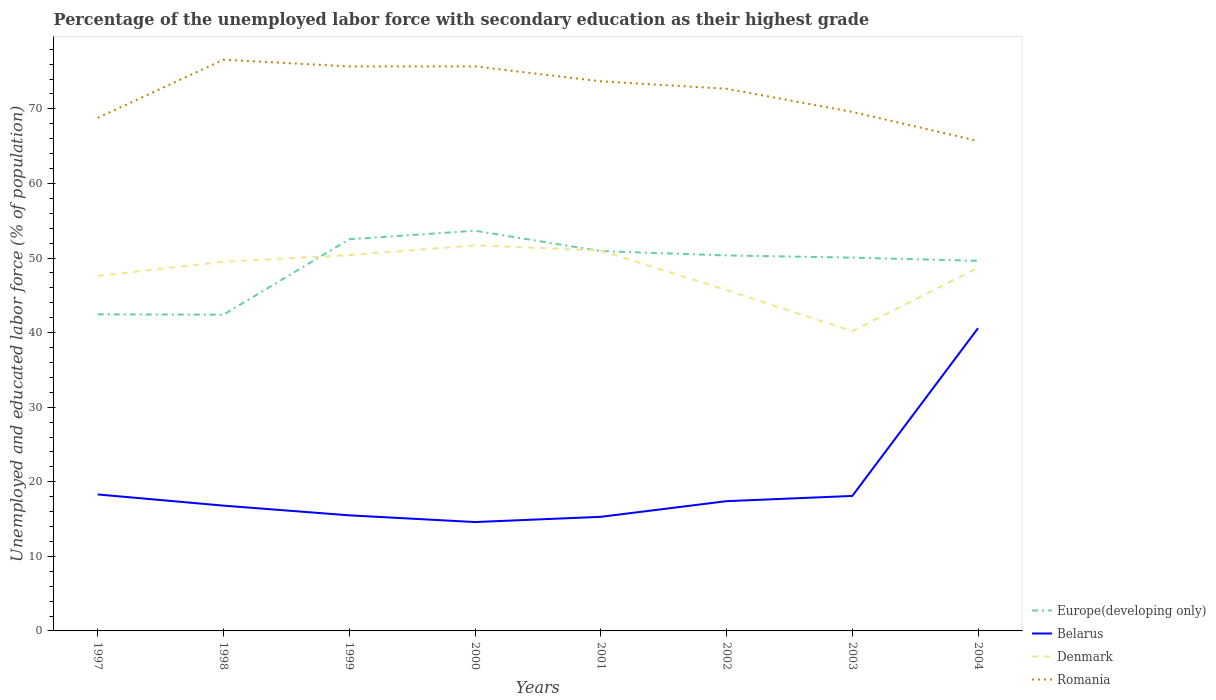Across all years, what is the maximum percentage of the unemployed labor force with secondary education in Romania?
Provide a short and direct response. 65.7. What is the total percentage of the unemployed labor force with secondary education in Romania in the graph?
Provide a short and direct response. 3.1. What is the difference between the highest and the second highest percentage of the unemployed labor force with secondary education in Europe(developing only)?
Offer a very short reply. 11.26. What is the difference between the highest and the lowest percentage of the unemployed labor force with secondary education in Europe(developing only)?
Your answer should be compact. 6. How many years are there in the graph?
Keep it short and to the point. 8. Are the values on the major ticks of Y-axis written in scientific E-notation?
Make the answer very short. No. Where does the legend appear in the graph?
Ensure brevity in your answer.  Bottom right. How are the legend labels stacked?
Give a very brief answer. Vertical. What is the title of the graph?
Ensure brevity in your answer.  Percentage of the unemployed labor force with secondary education as their highest grade. Does "Morocco" appear as one of the legend labels in the graph?
Offer a terse response. No. What is the label or title of the Y-axis?
Your answer should be very brief. Unemployed and educated labor force (% of population). What is the Unemployed and educated labor force (% of population) of Europe(developing only) in 1997?
Provide a succinct answer. 42.45. What is the Unemployed and educated labor force (% of population) in Belarus in 1997?
Give a very brief answer. 18.3. What is the Unemployed and educated labor force (% of population) of Denmark in 1997?
Your response must be concise. 47.6. What is the Unemployed and educated labor force (% of population) in Romania in 1997?
Make the answer very short. 68.8. What is the Unemployed and educated labor force (% of population) in Europe(developing only) in 1998?
Your answer should be compact. 42.41. What is the Unemployed and educated labor force (% of population) of Belarus in 1998?
Your answer should be very brief. 16.8. What is the Unemployed and educated labor force (% of population) of Denmark in 1998?
Your answer should be compact. 49.5. What is the Unemployed and educated labor force (% of population) in Romania in 1998?
Keep it short and to the point. 76.6. What is the Unemployed and educated labor force (% of population) in Europe(developing only) in 1999?
Your answer should be very brief. 52.52. What is the Unemployed and educated labor force (% of population) of Belarus in 1999?
Keep it short and to the point. 15.5. What is the Unemployed and educated labor force (% of population) in Denmark in 1999?
Offer a terse response. 50.4. What is the Unemployed and educated labor force (% of population) in Romania in 1999?
Offer a terse response. 75.7. What is the Unemployed and educated labor force (% of population) in Europe(developing only) in 2000?
Your answer should be compact. 53.66. What is the Unemployed and educated labor force (% of population) of Belarus in 2000?
Provide a short and direct response. 14.6. What is the Unemployed and educated labor force (% of population) of Denmark in 2000?
Your answer should be compact. 51.7. What is the Unemployed and educated labor force (% of population) of Romania in 2000?
Give a very brief answer. 75.7. What is the Unemployed and educated labor force (% of population) in Europe(developing only) in 2001?
Offer a terse response. 50.93. What is the Unemployed and educated labor force (% of population) in Belarus in 2001?
Your answer should be compact. 15.3. What is the Unemployed and educated labor force (% of population) of Denmark in 2001?
Your response must be concise. 51. What is the Unemployed and educated labor force (% of population) of Romania in 2001?
Offer a terse response. 73.7. What is the Unemployed and educated labor force (% of population) in Europe(developing only) in 2002?
Provide a succinct answer. 50.35. What is the Unemployed and educated labor force (% of population) in Belarus in 2002?
Keep it short and to the point. 17.4. What is the Unemployed and educated labor force (% of population) in Denmark in 2002?
Make the answer very short. 45.7. What is the Unemployed and educated labor force (% of population) of Romania in 2002?
Provide a succinct answer. 72.7. What is the Unemployed and educated labor force (% of population) in Europe(developing only) in 2003?
Your answer should be compact. 50.06. What is the Unemployed and educated labor force (% of population) of Belarus in 2003?
Ensure brevity in your answer.  18.1. What is the Unemployed and educated labor force (% of population) of Denmark in 2003?
Provide a succinct answer. 40.2. What is the Unemployed and educated labor force (% of population) of Romania in 2003?
Make the answer very short. 69.6. What is the Unemployed and educated labor force (% of population) in Europe(developing only) in 2004?
Make the answer very short. 49.63. What is the Unemployed and educated labor force (% of population) in Belarus in 2004?
Your answer should be compact. 40.6. What is the Unemployed and educated labor force (% of population) in Denmark in 2004?
Offer a very short reply. 48.7. What is the Unemployed and educated labor force (% of population) in Romania in 2004?
Provide a short and direct response. 65.7. Across all years, what is the maximum Unemployed and educated labor force (% of population) in Europe(developing only)?
Give a very brief answer. 53.66. Across all years, what is the maximum Unemployed and educated labor force (% of population) of Belarus?
Keep it short and to the point. 40.6. Across all years, what is the maximum Unemployed and educated labor force (% of population) of Denmark?
Your response must be concise. 51.7. Across all years, what is the maximum Unemployed and educated labor force (% of population) of Romania?
Your response must be concise. 76.6. Across all years, what is the minimum Unemployed and educated labor force (% of population) in Europe(developing only)?
Provide a succinct answer. 42.41. Across all years, what is the minimum Unemployed and educated labor force (% of population) of Belarus?
Provide a short and direct response. 14.6. Across all years, what is the minimum Unemployed and educated labor force (% of population) in Denmark?
Offer a terse response. 40.2. Across all years, what is the minimum Unemployed and educated labor force (% of population) of Romania?
Provide a succinct answer. 65.7. What is the total Unemployed and educated labor force (% of population) of Europe(developing only) in the graph?
Offer a terse response. 392.02. What is the total Unemployed and educated labor force (% of population) in Belarus in the graph?
Provide a short and direct response. 156.6. What is the total Unemployed and educated labor force (% of population) of Denmark in the graph?
Your answer should be very brief. 384.8. What is the total Unemployed and educated labor force (% of population) in Romania in the graph?
Provide a succinct answer. 578.5. What is the difference between the Unemployed and educated labor force (% of population) in Europe(developing only) in 1997 and that in 1998?
Your answer should be very brief. 0.05. What is the difference between the Unemployed and educated labor force (% of population) of Romania in 1997 and that in 1998?
Your answer should be compact. -7.8. What is the difference between the Unemployed and educated labor force (% of population) of Europe(developing only) in 1997 and that in 1999?
Your response must be concise. -10.07. What is the difference between the Unemployed and educated labor force (% of population) in Europe(developing only) in 1997 and that in 2000?
Keep it short and to the point. -11.21. What is the difference between the Unemployed and educated labor force (% of population) of Denmark in 1997 and that in 2000?
Give a very brief answer. -4.1. What is the difference between the Unemployed and educated labor force (% of population) of Romania in 1997 and that in 2000?
Provide a short and direct response. -6.9. What is the difference between the Unemployed and educated labor force (% of population) in Europe(developing only) in 1997 and that in 2001?
Provide a succinct answer. -8.48. What is the difference between the Unemployed and educated labor force (% of population) in Europe(developing only) in 1997 and that in 2002?
Offer a terse response. -7.9. What is the difference between the Unemployed and educated labor force (% of population) in Denmark in 1997 and that in 2002?
Make the answer very short. 1.9. What is the difference between the Unemployed and educated labor force (% of population) of Romania in 1997 and that in 2002?
Make the answer very short. -3.9. What is the difference between the Unemployed and educated labor force (% of population) in Europe(developing only) in 1997 and that in 2003?
Offer a terse response. -7.61. What is the difference between the Unemployed and educated labor force (% of population) of Romania in 1997 and that in 2003?
Give a very brief answer. -0.8. What is the difference between the Unemployed and educated labor force (% of population) in Europe(developing only) in 1997 and that in 2004?
Offer a very short reply. -7.17. What is the difference between the Unemployed and educated labor force (% of population) of Belarus in 1997 and that in 2004?
Provide a short and direct response. -22.3. What is the difference between the Unemployed and educated labor force (% of population) in Denmark in 1997 and that in 2004?
Offer a terse response. -1.1. What is the difference between the Unemployed and educated labor force (% of population) of Europe(developing only) in 1998 and that in 1999?
Give a very brief answer. -10.12. What is the difference between the Unemployed and educated labor force (% of population) in Europe(developing only) in 1998 and that in 2000?
Offer a terse response. -11.26. What is the difference between the Unemployed and educated labor force (% of population) in Denmark in 1998 and that in 2000?
Ensure brevity in your answer.  -2.2. What is the difference between the Unemployed and educated labor force (% of population) of Europe(developing only) in 1998 and that in 2001?
Your answer should be very brief. -8.53. What is the difference between the Unemployed and educated labor force (% of population) in Romania in 1998 and that in 2001?
Ensure brevity in your answer.  2.9. What is the difference between the Unemployed and educated labor force (% of population) of Europe(developing only) in 1998 and that in 2002?
Your answer should be very brief. -7.94. What is the difference between the Unemployed and educated labor force (% of population) of Belarus in 1998 and that in 2002?
Ensure brevity in your answer.  -0.6. What is the difference between the Unemployed and educated labor force (% of population) of Europe(developing only) in 1998 and that in 2003?
Give a very brief answer. -7.65. What is the difference between the Unemployed and educated labor force (% of population) of Denmark in 1998 and that in 2003?
Your answer should be compact. 9.3. What is the difference between the Unemployed and educated labor force (% of population) in Europe(developing only) in 1998 and that in 2004?
Your answer should be compact. -7.22. What is the difference between the Unemployed and educated labor force (% of population) of Belarus in 1998 and that in 2004?
Provide a short and direct response. -23.8. What is the difference between the Unemployed and educated labor force (% of population) in Romania in 1998 and that in 2004?
Provide a short and direct response. 10.9. What is the difference between the Unemployed and educated labor force (% of population) of Europe(developing only) in 1999 and that in 2000?
Give a very brief answer. -1.14. What is the difference between the Unemployed and educated labor force (% of population) of Belarus in 1999 and that in 2000?
Offer a very short reply. 0.9. What is the difference between the Unemployed and educated labor force (% of population) of Denmark in 1999 and that in 2000?
Keep it short and to the point. -1.3. What is the difference between the Unemployed and educated labor force (% of population) in Europe(developing only) in 1999 and that in 2001?
Make the answer very short. 1.59. What is the difference between the Unemployed and educated labor force (% of population) in Denmark in 1999 and that in 2001?
Keep it short and to the point. -0.6. What is the difference between the Unemployed and educated labor force (% of population) of Romania in 1999 and that in 2001?
Give a very brief answer. 2. What is the difference between the Unemployed and educated labor force (% of population) of Europe(developing only) in 1999 and that in 2002?
Keep it short and to the point. 2.17. What is the difference between the Unemployed and educated labor force (% of population) of Denmark in 1999 and that in 2002?
Keep it short and to the point. 4.7. What is the difference between the Unemployed and educated labor force (% of population) of Europe(developing only) in 1999 and that in 2003?
Make the answer very short. 2.46. What is the difference between the Unemployed and educated labor force (% of population) in Romania in 1999 and that in 2003?
Make the answer very short. 6.1. What is the difference between the Unemployed and educated labor force (% of population) in Europe(developing only) in 1999 and that in 2004?
Keep it short and to the point. 2.9. What is the difference between the Unemployed and educated labor force (% of population) of Belarus in 1999 and that in 2004?
Provide a succinct answer. -25.1. What is the difference between the Unemployed and educated labor force (% of population) in Denmark in 1999 and that in 2004?
Make the answer very short. 1.7. What is the difference between the Unemployed and educated labor force (% of population) of Europe(developing only) in 2000 and that in 2001?
Provide a short and direct response. 2.73. What is the difference between the Unemployed and educated labor force (% of population) in Belarus in 2000 and that in 2001?
Your answer should be compact. -0.7. What is the difference between the Unemployed and educated labor force (% of population) in Europe(developing only) in 2000 and that in 2002?
Provide a succinct answer. 3.31. What is the difference between the Unemployed and educated labor force (% of population) in Romania in 2000 and that in 2002?
Provide a short and direct response. 3. What is the difference between the Unemployed and educated labor force (% of population) in Europe(developing only) in 2000 and that in 2003?
Give a very brief answer. 3.6. What is the difference between the Unemployed and educated labor force (% of population) in Denmark in 2000 and that in 2003?
Offer a very short reply. 11.5. What is the difference between the Unemployed and educated labor force (% of population) of Europe(developing only) in 2000 and that in 2004?
Your response must be concise. 4.04. What is the difference between the Unemployed and educated labor force (% of population) of Belarus in 2000 and that in 2004?
Keep it short and to the point. -26. What is the difference between the Unemployed and educated labor force (% of population) in Europe(developing only) in 2001 and that in 2002?
Make the answer very short. 0.58. What is the difference between the Unemployed and educated labor force (% of population) in Denmark in 2001 and that in 2002?
Make the answer very short. 5.3. What is the difference between the Unemployed and educated labor force (% of population) in Romania in 2001 and that in 2002?
Make the answer very short. 1. What is the difference between the Unemployed and educated labor force (% of population) in Europe(developing only) in 2001 and that in 2003?
Your answer should be compact. 0.88. What is the difference between the Unemployed and educated labor force (% of population) of Belarus in 2001 and that in 2003?
Provide a short and direct response. -2.8. What is the difference between the Unemployed and educated labor force (% of population) of Romania in 2001 and that in 2003?
Provide a succinct answer. 4.1. What is the difference between the Unemployed and educated labor force (% of population) of Europe(developing only) in 2001 and that in 2004?
Make the answer very short. 1.31. What is the difference between the Unemployed and educated labor force (% of population) in Belarus in 2001 and that in 2004?
Your response must be concise. -25.3. What is the difference between the Unemployed and educated labor force (% of population) of Romania in 2001 and that in 2004?
Make the answer very short. 8. What is the difference between the Unemployed and educated labor force (% of population) of Europe(developing only) in 2002 and that in 2003?
Keep it short and to the point. 0.29. What is the difference between the Unemployed and educated labor force (% of population) of Belarus in 2002 and that in 2003?
Offer a terse response. -0.7. What is the difference between the Unemployed and educated labor force (% of population) of Denmark in 2002 and that in 2003?
Give a very brief answer. 5.5. What is the difference between the Unemployed and educated labor force (% of population) in Romania in 2002 and that in 2003?
Your answer should be compact. 3.1. What is the difference between the Unemployed and educated labor force (% of population) of Europe(developing only) in 2002 and that in 2004?
Offer a very short reply. 0.72. What is the difference between the Unemployed and educated labor force (% of population) of Belarus in 2002 and that in 2004?
Offer a terse response. -23.2. What is the difference between the Unemployed and educated labor force (% of population) of Europe(developing only) in 2003 and that in 2004?
Your response must be concise. 0.43. What is the difference between the Unemployed and educated labor force (% of population) in Belarus in 2003 and that in 2004?
Your answer should be very brief. -22.5. What is the difference between the Unemployed and educated labor force (% of population) in Europe(developing only) in 1997 and the Unemployed and educated labor force (% of population) in Belarus in 1998?
Your answer should be very brief. 25.65. What is the difference between the Unemployed and educated labor force (% of population) of Europe(developing only) in 1997 and the Unemployed and educated labor force (% of population) of Denmark in 1998?
Keep it short and to the point. -7.05. What is the difference between the Unemployed and educated labor force (% of population) of Europe(developing only) in 1997 and the Unemployed and educated labor force (% of population) of Romania in 1998?
Make the answer very short. -34.15. What is the difference between the Unemployed and educated labor force (% of population) in Belarus in 1997 and the Unemployed and educated labor force (% of population) in Denmark in 1998?
Offer a terse response. -31.2. What is the difference between the Unemployed and educated labor force (% of population) of Belarus in 1997 and the Unemployed and educated labor force (% of population) of Romania in 1998?
Offer a very short reply. -58.3. What is the difference between the Unemployed and educated labor force (% of population) of Denmark in 1997 and the Unemployed and educated labor force (% of population) of Romania in 1998?
Keep it short and to the point. -29. What is the difference between the Unemployed and educated labor force (% of population) in Europe(developing only) in 1997 and the Unemployed and educated labor force (% of population) in Belarus in 1999?
Your response must be concise. 26.95. What is the difference between the Unemployed and educated labor force (% of population) of Europe(developing only) in 1997 and the Unemployed and educated labor force (% of population) of Denmark in 1999?
Keep it short and to the point. -7.95. What is the difference between the Unemployed and educated labor force (% of population) in Europe(developing only) in 1997 and the Unemployed and educated labor force (% of population) in Romania in 1999?
Your answer should be compact. -33.25. What is the difference between the Unemployed and educated labor force (% of population) in Belarus in 1997 and the Unemployed and educated labor force (% of population) in Denmark in 1999?
Your answer should be compact. -32.1. What is the difference between the Unemployed and educated labor force (% of population) in Belarus in 1997 and the Unemployed and educated labor force (% of population) in Romania in 1999?
Offer a terse response. -57.4. What is the difference between the Unemployed and educated labor force (% of population) in Denmark in 1997 and the Unemployed and educated labor force (% of population) in Romania in 1999?
Ensure brevity in your answer.  -28.1. What is the difference between the Unemployed and educated labor force (% of population) of Europe(developing only) in 1997 and the Unemployed and educated labor force (% of population) of Belarus in 2000?
Make the answer very short. 27.85. What is the difference between the Unemployed and educated labor force (% of population) of Europe(developing only) in 1997 and the Unemployed and educated labor force (% of population) of Denmark in 2000?
Keep it short and to the point. -9.25. What is the difference between the Unemployed and educated labor force (% of population) of Europe(developing only) in 1997 and the Unemployed and educated labor force (% of population) of Romania in 2000?
Provide a short and direct response. -33.25. What is the difference between the Unemployed and educated labor force (% of population) in Belarus in 1997 and the Unemployed and educated labor force (% of population) in Denmark in 2000?
Your answer should be very brief. -33.4. What is the difference between the Unemployed and educated labor force (% of population) in Belarus in 1997 and the Unemployed and educated labor force (% of population) in Romania in 2000?
Your answer should be very brief. -57.4. What is the difference between the Unemployed and educated labor force (% of population) of Denmark in 1997 and the Unemployed and educated labor force (% of population) of Romania in 2000?
Ensure brevity in your answer.  -28.1. What is the difference between the Unemployed and educated labor force (% of population) of Europe(developing only) in 1997 and the Unemployed and educated labor force (% of population) of Belarus in 2001?
Provide a short and direct response. 27.15. What is the difference between the Unemployed and educated labor force (% of population) of Europe(developing only) in 1997 and the Unemployed and educated labor force (% of population) of Denmark in 2001?
Offer a very short reply. -8.55. What is the difference between the Unemployed and educated labor force (% of population) of Europe(developing only) in 1997 and the Unemployed and educated labor force (% of population) of Romania in 2001?
Keep it short and to the point. -31.25. What is the difference between the Unemployed and educated labor force (% of population) in Belarus in 1997 and the Unemployed and educated labor force (% of population) in Denmark in 2001?
Your answer should be compact. -32.7. What is the difference between the Unemployed and educated labor force (% of population) in Belarus in 1997 and the Unemployed and educated labor force (% of population) in Romania in 2001?
Your response must be concise. -55.4. What is the difference between the Unemployed and educated labor force (% of population) in Denmark in 1997 and the Unemployed and educated labor force (% of population) in Romania in 2001?
Ensure brevity in your answer.  -26.1. What is the difference between the Unemployed and educated labor force (% of population) of Europe(developing only) in 1997 and the Unemployed and educated labor force (% of population) of Belarus in 2002?
Offer a terse response. 25.05. What is the difference between the Unemployed and educated labor force (% of population) of Europe(developing only) in 1997 and the Unemployed and educated labor force (% of population) of Denmark in 2002?
Your answer should be compact. -3.25. What is the difference between the Unemployed and educated labor force (% of population) of Europe(developing only) in 1997 and the Unemployed and educated labor force (% of population) of Romania in 2002?
Make the answer very short. -30.25. What is the difference between the Unemployed and educated labor force (% of population) in Belarus in 1997 and the Unemployed and educated labor force (% of population) in Denmark in 2002?
Keep it short and to the point. -27.4. What is the difference between the Unemployed and educated labor force (% of population) of Belarus in 1997 and the Unemployed and educated labor force (% of population) of Romania in 2002?
Give a very brief answer. -54.4. What is the difference between the Unemployed and educated labor force (% of population) in Denmark in 1997 and the Unemployed and educated labor force (% of population) in Romania in 2002?
Offer a very short reply. -25.1. What is the difference between the Unemployed and educated labor force (% of population) of Europe(developing only) in 1997 and the Unemployed and educated labor force (% of population) of Belarus in 2003?
Your answer should be compact. 24.35. What is the difference between the Unemployed and educated labor force (% of population) of Europe(developing only) in 1997 and the Unemployed and educated labor force (% of population) of Denmark in 2003?
Keep it short and to the point. 2.25. What is the difference between the Unemployed and educated labor force (% of population) of Europe(developing only) in 1997 and the Unemployed and educated labor force (% of population) of Romania in 2003?
Provide a short and direct response. -27.15. What is the difference between the Unemployed and educated labor force (% of population) of Belarus in 1997 and the Unemployed and educated labor force (% of population) of Denmark in 2003?
Your answer should be compact. -21.9. What is the difference between the Unemployed and educated labor force (% of population) in Belarus in 1997 and the Unemployed and educated labor force (% of population) in Romania in 2003?
Provide a short and direct response. -51.3. What is the difference between the Unemployed and educated labor force (% of population) in Denmark in 1997 and the Unemployed and educated labor force (% of population) in Romania in 2003?
Your answer should be compact. -22. What is the difference between the Unemployed and educated labor force (% of population) in Europe(developing only) in 1997 and the Unemployed and educated labor force (% of population) in Belarus in 2004?
Offer a very short reply. 1.85. What is the difference between the Unemployed and educated labor force (% of population) of Europe(developing only) in 1997 and the Unemployed and educated labor force (% of population) of Denmark in 2004?
Your response must be concise. -6.25. What is the difference between the Unemployed and educated labor force (% of population) of Europe(developing only) in 1997 and the Unemployed and educated labor force (% of population) of Romania in 2004?
Offer a terse response. -23.25. What is the difference between the Unemployed and educated labor force (% of population) of Belarus in 1997 and the Unemployed and educated labor force (% of population) of Denmark in 2004?
Your answer should be compact. -30.4. What is the difference between the Unemployed and educated labor force (% of population) of Belarus in 1997 and the Unemployed and educated labor force (% of population) of Romania in 2004?
Give a very brief answer. -47.4. What is the difference between the Unemployed and educated labor force (% of population) of Denmark in 1997 and the Unemployed and educated labor force (% of population) of Romania in 2004?
Offer a very short reply. -18.1. What is the difference between the Unemployed and educated labor force (% of population) in Europe(developing only) in 1998 and the Unemployed and educated labor force (% of population) in Belarus in 1999?
Offer a very short reply. 26.91. What is the difference between the Unemployed and educated labor force (% of population) of Europe(developing only) in 1998 and the Unemployed and educated labor force (% of population) of Denmark in 1999?
Offer a terse response. -7.99. What is the difference between the Unemployed and educated labor force (% of population) in Europe(developing only) in 1998 and the Unemployed and educated labor force (% of population) in Romania in 1999?
Ensure brevity in your answer.  -33.29. What is the difference between the Unemployed and educated labor force (% of population) of Belarus in 1998 and the Unemployed and educated labor force (% of population) of Denmark in 1999?
Keep it short and to the point. -33.6. What is the difference between the Unemployed and educated labor force (% of population) in Belarus in 1998 and the Unemployed and educated labor force (% of population) in Romania in 1999?
Your answer should be compact. -58.9. What is the difference between the Unemployed and educated labor force (% of population) in Denmark in 1998 and the Unemployed and educated labor force (% of population) in Romania in 1999?
Make the answer very short. -26.2. What is the difference between the Unemployed and educated labor force (% of population) in Europe(developing only) in 1998 and the Unemployed and educated labor force (% of population) in Belarus in 2000?
Your answer should be very brief. 27.81. What is the difference between the Unemployed and educated labor force (% of population) of Europe(developing only) in 1998 and the Unemployed and educated labor force (% of population) of Denmark in 2000?
Offer a very short reply. -9.29. What is the difference between the Unemployed and educated labor force (% of population) in Europe(developing only) in 1998 and the Unemployed and educated labor force (% of population) in Romania in 2000?
Your response must be concise. -33.29. What is the difference between the Unemployed and educated labor force (% of population) of Belarus in 1998 and the Unemployed and educated labor force (% of population) of Denmark in 2000?
Ensure brevity in your answer.  -34.9. What is the difference between the Unemployed and educated labor force (% of population) in Belarus in 1998 and the Unemployed and educated labor force (% of population) in Romania in 2000?
Offer a very short reply. -58.9. What is the difference between the Unemployed and educated labor force (% of population) of Denmark in 1998 and the Unemployed and educated labor force (% of population) of Romania in 2000?
Offer a very short reply. -26.2. What is the difference between the Unemployed and educated labor force (% of population) in Europe(developing only) in 1998 and the Unemployed and educated labor force (% of population) in Belarus in 2001?
Provide a short and direct response. 27.11. What is the difference between the Unemployed and educated labor force (% of population) of Europe(developing only) in 1998 and the Unemployed and educated labor force (% of population) of Denmark in 2001?
Provide a short and direct response. -8.59. What is the difference between the Unemployed and educated labor force (% of population) of Europe(developing only) in 1998 and the Unemployed and educated labor force (% of population) of Romania in 2001?
Offer a very short reply. -31.29. What is the difference between the Unemployed and educated labor force (% of population) in Belarus in 1998 and the Unemployed and educated labor force (% of population) in Denmark in 2001?
Keep it short and to the point. -34.2. What is the difference between the Unemployed and educated labor force (% of population) of Belarus in 1998 and the Unemployed and educated labor force (% of population) of Romania in 2001?
Offer a very short reply. -56.9. What is the difference between the Unemployed and educated labor force (% of population) in Denmark in 1998 and the Unemployed and educated labor force (% of population) in Romania in 2001?
Ensure brevity in your answer.  -24.2. What is the difference between the Unemployed and educated labor force (% of population) of Europe(developing only) in 1998 and the Unemployed and educated labor force (% of population) of Belarus in 2002?
Your response must be concise. 25.01. What is the difference between the Unemployed and educated labor force (% of population) in Europe(developing only) in 1998 and the Unemployed and educated labor force (% of population) in Denmark in 2002?
Provide a short and direct response. -3.29. What is the difference between the Unemployed and educated labor force (% of population) in Europe(developing only) in 1998 and the Unemployed and educated labor force (% of population) in Romania in 2002?
Provide a succinct answer. -30.29. What is the difference between the Unemployed and educated labor force (% of population) in Belarus in 1998 and the Unemployed and educated labor force (% of population) in Denmark in 2002?
Keep it short and to the point. -28.9. What is the difference between the Unemployed and educated labor force (% of population) of Belarus in 1998 and the Unemployed and educated labor force (% of population) of Romania in 2002?
Give a very brief answer. -55.9. What is the difference between the Unemployed and educated labor force (% of population) in Denmark in 1998 and the Unemployed and educated labor force (% of population) in Romania in 2002?
Make the answer very short. -23.2. What is the difference between the Unemployed and educated labor force (% of population) in Europe(developing only) in 1998 and the Unemployed and educated labor force (% of population) in Belarus in 2003?
Your response must be concise. 24.31. What is the difference between the Unemployed and educated labor force (% of population) in Europe(developing only) in 1998 and the Unemployed and educated labor force (% of population) in Denmark in 2003?
Your answer should be very brief. 2.21. What is the difference between the Unemployed and educated labor force (% of population) of Europe(developing only) in 1998 and the Unemployed and educated labor force (% of population) of Romania in 2003?
Give a very brief answer. -27.19. What is the difference between the Unemployed and educated labor force (% of population) in Belarus in 1998 and the Unemployed and educated labor force (% of population) in Denmark in 2003?
Offer a very short reply. -23.4. What is the difference between the Unemployed and educated labor force (% of population) of Belarus in 1998 and the Unemployed and educated labor force (% of population) of Romania in 2003?
Provide a short and direct response. -52.8. What is the difference between the Unemployed and educated labor force (% of population) of Denmark in 1998 and the Unemployed and educated labor force (% of population) of Romania in 2003?
Make the answer very short. -20.1. What is the difference between the Unemployed and educated labor force (% of population) in Europe(developing only) in 1998 and the Unemployed and educated labor force (% of population) in Belarus in 2004?
Provide a succinct answer. 1.81. What is the difference between the Unemployed and educated labor force (% of population) in Europe(developing only) in 1998 and the Unemployed and educated labor force (% of population) in Denmark in 2004?
Make the answer very short. -6.29. What is the difference between the Unemployed and educated labor force (% of population) in Europe(developing only) in 1998 and the Unemployed and educated labor force (% of population) in Romania in 2004?
Your answer should be compact. -23.29. What is the difference between the Unemployed and educated labor force (% of population) of Belarus in 1998 and the Unemployed and educated labor force (% of population) of Denmark in 2004?
Your answer should be very brief. -31.9. What is the difference between the Unemployed and educated labor force (% of population) in Belarus in 1998 and the Unemployed and educated labor force (% of population) in Romania in 2004?
Offer a very short reply. -48.9. What is the difference between the Unemployed and educated labor force (% of population) of Denmark in 1998 and the Unemployed and educated labor force (% of population) of Romania in 2004?
Offer a very short reply. -16.2. What is the difference between the Unemployed and educated labor force (% of population) of Europe(developing only) in 1999 and the Unemployed and educated labor force (% of population) of Belarus in 2000?
Your response must be concise. 37.92. What is the difference between the Unemployed and educated labor force (% of population) of Europe(developing only) in 1999 and the Unemployed and educated labor force (% of population) of Denmark in 2000?
Provide a succinct answer. 0.82. What is the difference between the Unemployed and educated labor force (% of population) in Europe(developing only) in 1999 and the Unemployed and educated labor force (% of population) in Romania in 2000?
Give a very brief answer. -23.18. What is the difference between the Unemployed and educated labor force (% of population) of Belarus in 1999 and the Unemployed and educated labor force (% of population) of Denmark in 2000?
Keep it short and to the point. -36.2. What is the difference between the Unemployed and educated labor force (% of population) of Belarus in 1999 and the Unemployed and educated labor force (% of population) of Romania in 2000?
Make the answer very short. -60.2. What is the difference between the Unemployed and educated labor force (% of population) of Denmark in 1999 and the Unemployed and educated labor force (% of population) of Romania in 2000?
Offer a terse response. -25.3. What is the difference between the Unemployed and educated labor force (% of population) in Europe(developing only) in 1999 and the Unemployed and educated labor force (% of population) in Belarus in 2001?
Offer a terse response. 37.22. What is the difference between the Unemployed and educated labor force (% of population) in Europe(developing only) in 1999 and the Unemployed and educated labor force (% of population) in Denmark in 2001?
Make the answer very short. 1.52. What is the difference between the Unemployed and educated labor force (% of population) in Europe(developing only) in 1999 and the Unemployed and educated labor force (% of population) in Romania in 2001?
Ensure brevity in your answer.  -21.18. What is the difference between the Unemployed and educated labor force (% of population) of Belarus in 1999 and the Unemployed and educated labor force (% of population) of Denmark in 2001?
Keep it short and to the point. -35.5. What is the difference between the Unemployed and educated labor force (% of population) of Belarus in 1999 and the Unemployed and educated labor force (% of population) of Romania in 2001?
Offer a very short reply. -58.2. What is the difference between the Unemployed and educated labor force (% of population) in Denmark in 1999 and the Unemployed and educated labor force (% of population) in Romania in 2001?
Provide a succinct answer. -23.3. What is the difference between the Unemployed and educated labor force (% of population) in Europe(developing only) in 1999 and the Unemployed and educated labor force (% of population) in Belarus in 2002?
Give a very brief answer. 35.12. What is the difference between the Unemployed and educated labor force (% of population) of Europe(developing only) in 1999 and the Unemployed and educated labor force (% of population) of Denmark in 2002?
Provide a succinct answer. 6.82. What is the difference between the Unemployed and educated labor force (% of population) in Europe(developing only) in 1999 and the Unemployed and educated labor force (% of population) in Romania in 2002?
Give a very brief answer. -20.18. What is the difference between the Unemployed and educated labor force (% of population) in Belarus in 1999 and the Unemployed and educated labor force (% of population) in Denmark in 2002?
Offer a very short reply. -30.2. What is the difference between the Unemployed and educated labor force (% of population) in Belarus in 1999 and the Unemployed and educated labor force (% of population) in Romania in 2002?
Ensure brevity in your answer.  -57.2. What is the difference between the Unemployed and educated labor force (% of population) of Denmark in 1999 and the Unemployed and educated labor force (% of population) of Romania in 2002?
Offer a very short reply. -22.3. What is the difference between the Unemployed and educated labor force (% of population) of Europe(developing only) in 1999 and the Unemployed and educated labor force (% of population) of Belarus in 2003?
Your response must be concise. 34.42. What is the difference between the Unemployed and educated labor force (% of population) of Europe(developing only) in 1999 and the Unemployed and educated labor force (% of population) of Denmark in 2003?
Offer a very short reply. 12.32. What is the difference between the Unemployed and educated labor force (% of population) in Europe(developing only) in 1999 and the Unemployed and educated labor force (% of population) in Romania in 2003?
Provide a short and direct response. -17.08. What is the difference between the Unemployed and educated labor force (% of population) of Belarus in 1999 and the Unemployed and educated labor force (% of population) of Denmark in 2003?
Provide a succinct answer. -24.7. What is the difference between the Unemployed and educated labor force (% of population) of Belarus in 1999 and the Unemployed and educated labor force (% of population) of Romania in 2003?
Provide a short and direct response. -54.1. What is the difference between the Unemployed and educated labor force (% of population) of Denmark in 1999 and the Unemployed and educated labor force (% of population) of Romania in 2003?
Provide a short and direct response. -19.2. What is the difference between the Unemployed and educated labor force (% of population) of Europe(developing only) in 1999 and the Unemployed and educated labor force (% of population) of Belarus in 2004?
Your response must be concise. 11.92. What is the difference between the Unemployed and educated labor force (% of population) of Europe(developing only) in 1999 and the Unemployed and educated labor force (% of population) of Denmark in 2004?
Your answer should be compact. 3.82. What is the difference between the Unemployed and educated labor force (% of population) of Europe(developing only) in 1999 and the Unemployed and educated labor force (% of population) of Romania in 2004?
Your answer should be very brief. -13.18. What is the difference between the Unemployed and educated labor force (% of population) in Belarus in 1999 and the Unemployed and educated labor force (% of population) in Denmark in 2004?
Make the answer very short. -33.2. What is the difference between the Unemployed and educated labor force (% of population) in Belarus in 1999 and the Unemployed and educated labor force (% of population) in Romania in 2004?
Your answer should be very brief. -50.2. What is the difference between the Unemployed and educated labor force (% of population) of Denmark in 1999 and the Unemployed and educated labor force (% of population) of Romania in 2004?
Provide a succinct answer. -15.3. What is the difference between the Unemployed and educated labor force (% of population) of Europe(developing only) in 2000 and the Unemployed and educated labor force (% of population) of Belarus in 2001?
Your answer should be compact. 38.36. What is the difference between the Unemployed and educated labor force (% of population) in Europe(developing only) in 2000 and the Unemployed and educated labor force (% of population) in Denmark in 2001?
Your answer should be very brief. 2.66. What is the difference between the Unemployed and educated labor force (% of population) in Europe(developing only) in 2000 and the Unemployed and educated labor force (% of population) in Romania in 2001?
Your answer should be compact. -20.04. What is the difference between the Unemployed and educated labor force (% of population) of Belarus in 2000 and the Unemployed and educated labor force (% of population) of Denmark in 2001?
Give a very brief answer. -36.4. What is the difference between the Unemployed and educated labor force (% of population) in Belarus in 2000 and the Unemployed and educated labor force (% of population) in Romania in 2001?
Your answer should be compact. -59.1. What is the difference between the Unemployed and educated labor force (% of population) of Europe(developing only) in 2000 and the Unemployed and educated labor force (% of population) of Belarus in 2002?
Give a very brief answer. 36.26. What is the difference between the Unemployed and educated labor force (% of population) of Europe(developing only) in 2000 and the Unemployed and educated labor force (% of population) of Denmark in 2002?
Make the answer very short. 7.96. What is the difference between the Unemployed and educated labor force (% of population) of Europe(developing only) in 2000 and the Unemployed and educated labor force (% of population) of Romania in 2002?
Keep it short and to the point. -19.04. What is the difference between the Unemployed and educated labor force (% of population) of Belarus in 2000 and the Unemployed and educated labor force (% of population) of Denmark in 2002?
Keep it short and to the point. -31.1. What is the difference between the Unemployed and educated labor force (% of population) of Belarus in 2000 and the Unemployed and educated labor force (% of population) of Romania in 2002?
Your response must be concise. -58.1. What is the difference between the Unemployed and educated labor force (% of population) in Europe(developing only) in 2000 and the Unemployed and educated labor force (% of population) in Belarus in 2003?
Your response must be concise. 35.56. What is the difference between the Unemployed and educated labor force (% of population) in Europe(developing only) in 2000 and the Unemployed and educated labor force (% of population) in Denmark in 2003?
Make the answer very short. 13.46. What is the difference between the Unemployed and educated labor force (% of population) of Europe(developing only) in 2000 and the Unemployed and educated labor force (% of population) of Romania in 2003?
Your response must be concise. -15.94. What is the difference between the Unemployed and educated labor force (% of population) in Belarus in 2000 and the Unemployed and educated labor force (% of population) in Denmark in 2003?
Offer a very short reply. -25.6. What is the difference between the Unemployed and educated labor force (% of population) in Belarus in 2000 and the Unemployed and educated labor force (% of population) in Romania in 2003?
Give a very brief answer. -55. What is the difference between the Unemployed and educated labor force (% of population) of Denmark in 2000 and the Unemployed and educated labor force (% of population) of Romania in 2003?
Keep it short and to the point. -17.9. What is the difference between the Unemployed and educated labor force (% of population) of Europe(developing only) in 2000 and the Unemployed and educated labor force (% of population) of Belarus in 2004?
Give a very brief answer. 13.06. What is the difference between the Unemployed and educated labor force (% of population) of Europe(developing only) in 2000 and the Unemployed and educated labor force (% of population) of Denmark in 2004?
Your response must be concise. 4.96. What is the difference between the Unemployed and educated labor force (% of population) of Europe(developing only) in 2000 and the Unemployed and educated labor force (% of population) of Romania in 2004?
Make the answer very short. -12.04. What is the difference between the Unemployed and educated labor force (% of population) in Belarus in 2000 and the Unemployed and educated labor force (% of population) in Denmark in 2004?
Provide a succinct answer. -34.1. What is the difference between the Unemployed and educated labor force (% of population) in Belarus in 2000 and the Unemployed and educated labor force (% of population) in Romania in 2004?
Provide a short and direct response. -51.1. What is the difference between the Unemployed and educated labor force (% of population) of Europe(developing only) in 2001 and the Unemployed and educated labor force (% of population) of Belarus in 2002?
Give a very brief answer. 33.53. What is the difference between the Unemployed and educated labor force (% of population) of Europe(developing only) in 2001 and the Unemployed and educated labor force (% of population) of Denmark in 2002?
Give a very brief answer. 5.24. What is the difference between the Unemployed and educated labor force (% of population) of Europe(developing only) in 2001 and the Unemployed and educated labor force (% of population) of Romania in 2002?
Ensure brevity in your answer.  -21.77. What is the difference between the Unemployed and educated labor force (% of population) of Belarus in 2001 and the Unemployed and educated labor force (% of population) of Denmark in 2002?
Provide a succinct answer. -30.4. What is the difference between the Unemployed and educated labor force (% of population) in Belarus in 2001 and the Unemployed and educated labor force (% of population) in Romania in 2002?
Offer a terse response. -57.4. What is the difference between the Unemployed and educated labor force (% of population) in Denmark in 2001 and the Unemployed and educated labor force (% of population) in Romania in 2002?
Provide a succinct answer. -21.7. What is the difference between the Unemployed and educated labor force (% of population) in Europe(developing only) in 2001 and the Unemployed and educated labor force (% of population) in Belarus in 2003?
Your answer should be very brief. 32.84. What is the difference between the Unemployed and educated labor force (% of population) of Europe(developing only) in 2001 and the Unemployed and educated labor force (% of population) of Denmark in 2003?
Offer a very short reply. 10.73. What is the difference between the Unemployed and educated labor force (% of population) in Europe(developing only) in 2001 and the Unemployed and educated labor force (% of population) in Romania in 2003?
Give a very brief answer. -18.66. What is the difference between the Unemployed and educated labor force (% of population) of Belarus in 2001 and the Unemployed and educated labor force (% of population) of Denmark in 2003?
Your answer should be very brief. -24.9. What is the difference between the Unemployed and educated labor force (% of population) in Belarus in 2001 and the Unemployed and educated labor force (% of population) in Romania in 2003?
Offer a very short reply. -54.3. What is the difference between the Unemployed and educated labor force (% of population) in Denmark in 2001 and the Unemployed and educated labor force (% of population) in Romania in 2003?
Your response must be concise. -18.6. What is the difference between the Unemployed and educated labor force (% of population) of Europe(developing only) in 2001 and the Unemployed and educated labor force (% of population) of Belarus in 2004?
Make the answer very short. 10.34. What is the difference between the Unemployed and educated labor force (% of population) in Europe(developing only) in 2001 and the Unemployed and educated labor force (% of population) in Denmark in 2004?
Your answer should be compact. 2.23. What is the difference between the Unemployed and educated labor force (% of population) of Europe(developing only) in 2001 and the Unemployed and educated labor force (% of population) of Romania in 2004?
Give a very brief answer. -14.77. What is the difference between the Unemployed and educated labor force (% of population) of Belarus in 2001 and the Unemployed and educated labor force (% of population) of Denmark in 2004?
Keep it short and to the point. -33.4. What is the difference between the Unemployed and educated labor force (% of population) of Belarus in 2001 and the Unemployed and educated labor force (% of population) of Romania in 2004?
Offer a terse response. -50.4. What is the difference between the Unemployed and educated labor force (% of population) of Denmark in 2001 and the Unemployed and educated labor force (% of population) of Romania in 2004?
Provide a succinct answer. -14.7. What is the difference between the Unemployed and educated labor force (% of population) of Europe(developing only) in 2002 and the Unemployed and educated labor force (% of population) of Belarus in 2003?
Offer a terse response. 32.25. What is the difference between the Unemployed and educated labor force (% of population) in Europe(developing only) in 2002 and the Unemployed and educated labor force (% of population) in Denmark in 2003?
Your answer should be very brief. 10.15. What is the difference between the Unemployed and educated labor force (% of population) in Europe(developing only) in 2002 and the Unemployed and educated labor force (% of population) in Romania in 2003?
Your response must be concise. -19.25. What is the difference between the Unemployed and educated labor force (% of population) in Belarus in 2002 and the Unemployed and educated labor force (% of population) in Denmark in 2003?
Make the answer very short. -22.8. What is the difference between the Unemployed and educated labor force (% of population) of Belarus in 2002 and the Unemployed and educated labor force (% of population) of Romania in 2003?
Provide a short and direct response. -52.2. What is the difference between the Unemployed and educated labor force (% of population) in Denmark in 2002 and the Unemployed and educated labor force (% of population) in Romania in 2003?
Keep it short and to the point. -23.9. What is the difference between the Unemployed and educated labor force (% of population) in Europe(developing only) in 2002 and the Unemployed and educated labor force (% of population) in Belarus in 2004?
Provide a succinct answer. 9.75. What is the difference between the Unemployed and educated labor force (% of population) of Europe(developing only) in 2002 and the Unemployed and educated labor force (% of population) of Denmark in 2004?
Ensure brevity in your answer.  1.65. What is the difference between the Unemployed and educated labor force (% of population) in Europe(developing only) in 2002 and the Unemployed and educated labor force (% of population) in Romania in 2004?
Make the answer very short. -15.35. What is the difference between the Unemployed and educated labor force (% of population) of Belarus in 2002 and the Unemployed and educated labor force (% of population) of Denmark in 2004?
Your response must be concise. -31.3. What is the difference between the Unemployed and educated labor force (% of population) of Belarus in 2002 and the Unemployed and educated labor force (% of population) of Romania in 2004?
Offer a very short reply. -48.3. What is the difference between the Unemployed and educated labor force (% of population) of Denmark in 2002 and the Unemployed and educated labor force (% of population) of Romania in 2004?
Keep it short and to the point. -20. What is the difference between the Unemployed and educated labor force (% of population) of Europe(developing only) in 2003 and the Unemployed and educated labor force (% of population) of Belarus in 2004?
Make the answer very short. 9.46. What is the difference between the Unemployed and educated labor force (% of population) in Europe(developing only) in 2003 and the Unemployed and educated labor force (% of population) in Denmark in 2004?
Your answer should be compact. 1.36. What is the difference between the Unemployed and educated labor force (% of population) of Europe(developing only) in 2003 and the Unemployed and educated labor force (% of population) of Romania in 2004?
Provide a succinct answer. -15.64. What is the difference between the Unemployed and educated labor force (% of population) of Belarus in 2003 and the Unemployed and educated labor force (% of population) of Denmark in 2004?
Offer a terse response. -30.6. What is the difference between the Unemployed and educated labor force (% of population) of Belarus in 2003 and the Unemployed and educated labor force (% of population) of Romania in 2004?
Provide a succinct answer. -47.6. What is the difference between the Unemployed and educated labor force (% of population) in Denmark in 2003 and the Unemployed and educated labor force (% of population) in Romania in 2004?
Provide a succinct answer. -25.5. What is the average Unemployed and educated labor force (% of population) of Europe(developing only) per year?
Offer a very short reply. 49. What is the average Unemployed and educated labor force (% of population) in Belarus per year?
Your answer should be very brief. 19.57. What is the average Unemployed and educated labor force (% of population) in Denmark per year?
Make the answer very short. 48.1. What is the average Unemployed and educated labor force (% of population) of Romania per year?
Ensure brevity in your answer.  72.31. In the year 1997, what is the difference between the Unemployed and educated labor force (% of population) in Europe(developing only) and Unemployed and educated labor force (% of population) in Belarus?
Provide a succinct answer. 24.15. In the year 1997, what is the difference between the Unemployed and educated labor force (% of population) in Europe(developing only) and Unemployed and educated labor force (% of population) in Denmark?
Provide a succinct answer. -5.15. In the year 1997, what is the difference between the Unemployed and educated labor force (% of population) in Europe(developing only) and Unemployed and educated labor force (% of population) in Romania?
Offer a terse response. -26.35. In the year 1997, what is the difference between the Unemployed and educated labor force (% of population) in Belarus and Unemployed and educated labor force (% of population) in Denmark?
Your answer should be compact. -29.3. In the year 1997, what is the difference between the Unemployed and educated labor force (% of population) of Belarus and Unemployed and educated labor force (% of population) of Romania?
Ensure brevity in your answer.  -50.5. In the year 1997, what is the difference between the Unemployed and educated labor force (% of population) in Denmark and Unemployed and educated labor force (% of population) in Romania?
Ensure brevity in your answer.  -21.2. In the year 1998, what is the difference between the Unemployed and educated labor force (% of population) of Europe(developing only) and Unemployed and educated labor force (% of population) of Belarus?
Give a very brief answer. 25.61. In the year 1998, what is the difference between the Unemployed and educated labor force (% of population) in Europe(developing only) and Unemployed and educated labor force (% of population) in Denmark?
Provide a short and direct response. -7.09. In the year 1998, what is the difference between the Unemployed and educated labor force (% of population) of Europe(developing only) and Unemployed and educated labor force (% of population) of Romania?
Make the answer very short. -34.19. In the year 1998, what is the difference between the Unemployed and educated labor force (% of population) in Belarus and Unemployed and educated labor force (% of population) in Denmark?
Give a very brief answer. -32.7. In the year 1998, what is the difference between the Unemployed and educated labor force (% of population) of Belarus and Unemployed and educated labor force (% of population) of Romania?
Your response must be concise. -59.8. In the year 1998, what is the difference between the Unemployed and educated labor force (% of population) of Denmark and Unemployed and educated labor force (% of population) of Romania?
Make the answer very short. -27.1. In the year 1999, what is the difference between the Unemployed and educated labor force (% of population) in Europe(developing only) and Unemployed and educated labor force (% of population) in Belarus?
Your answer should be compact. 37.02. In the year 1999, what is the difference between the Unemployed and educated labor force (% of population) in Europe(developing only) and Unemployed and educated labor force (% of population) in Denmark?
Ensure brevity in your answer.  2.12. In the year 1999, what is the difference between the Unemployed and educated labor force (% of population) in Europe(developing only) and Unemployed and educated labor force (% of population) in Romania?
Offer a very short reply. -23.18. In the year 1999, what is the difference between the Unemployed and educated labor force (% of population) of Belarus and Unemployed and educated labor force (% of population) of Denmark?
Make the answer very short. -34.9. In the year 1999, what is the difference between the Unemployed and educated labor force (% of population) of Belarus and Unemployed and educated labor force (% of population) of Romania?
Ensure brevity in your answer.  -60.2. In the year 1999, what is the difference between the Unemployed and educated labor force (% of population) in Denmark and Unemployed and educated labor force (% of population) in Romania?
Your answer should be compact. -25.3. In the year 2000, what is the difference between the Unemployed and educated labor force (% of population) in Europe(developing only) and Unemployed and educated labor force (% of population) in Belarus?
Ensure brevity in your answer.  39.06. In the year 2000, what is the difference between the Unemployed and educated labor force (% of population) of Europe(developing only) and Unemployed and educated labor force (% of population) of Denmark?
Provide a short and direct response. 1.96. In the year 2000, what is the difference between the Unemployed and educated labor force (% of population) of Europe(developing only) and Unemployed and educated labor force (% of population) of Romania?
Your answer should be very brief. -22.04. In the year 2000, what is the difference between the Unemployed and educated labor force (% of population) of Belarus and Unemployed and educated labor force (% of population) of Denmark?
Your response must be concise. -37.1. In the year 2000, what is the difference between the Unemployed and educated labor force (% of population) of Belarus and Unemployed and educated labor force (% of population) of Romania?
Provide a short and direct response. -61.1. In the year 2000, what is the difference between the Unemployed and educated labor force (% of population) of Denmark and Unemployed and educated labor force (% of population) of Romania?
Offer a terse response. -24. In the year 2001, what is the difference between the Unemployed and educated labor force (% of population) of Europe(developing only) and Unemployed and educated labor force (% of population) of Belarus?
Give a very brief answer. 35.63. In the year 2001, what is the difference between the Unemployed and educated labor force (% of population) in Europe(developing only) and Unemployed and educated labor force (% of population) in Denmark?
Provide a succinct answer. -0.07. In the year 2001, what is the difference between the Unemployed and educated labor force (% of population) of Europe(developing only) and Unemployed and educated labor force (% of population) of Romania?
Give a very brief answer. -22.77. In the year 2001, what is the difference between the Unemployed and educated labor force (% of population) of Belarus and Unemployed and educated labor force (% of population) of Denmark?
Offer a very short reply. -35.7. In the year 2001, what is the difference between the Unemployed and educated labor force (% of population) of Belarus and Unemployed and educated labor force (% of population) of Romania?
Ensure brevity in your answer.  -58.4. In the year 2001, what is the difference between the Unemployed and educated labor force (% of population) of Denmark and Unemployed and educated labor force (% of population) of Romania?
Offer a very short reply. -22.7. In the year 2002, what is the difference between the Unemployed and educated labor force (% of population) in Europe(developing only) and Unemployed and educated labor force (% of population) in Belarus?
Give a very brief answer. 32.95. In the year 2002, what is the difference between the Unemployed and educated labor force (% of population) of Europe(developing only) and Unemployed and educated labor force (% of population) of Denmark?
Provide a short and direct response. 4.65. In the year 2002, what is the difference between the Unemployed and educated labor force (% of population) of Europe(developing only) and Unemployed and educated labor force (% of population) of Romania?
Keep it short and to the point. -22.35. In the year 2002, what is the difference between the Unemployed and educated labor force (% of population) in Belarus and Unemployed and educated labor force (% of population) in Denmark?
Ensure brevity in your answer.  -28.3. In the year 2002, what is the difference between the Unemployed and educated labor force (% of population) in Belarus and Unemployed and educated labor force (% of population) in Romania?
Provide a succinct answer. -55.3. In the year 2003, what is the difference between the Unemployed and educated labor force (% of population) of Europe(developing only) and Unemployed and educated labor force (% of population) of Belarus?
Keep it short and to the point. 31.96. In the year 2003, what is the difference between the Unemployed and educated labor force (% of population) of Europe(developing only) and Unemployed and educated labor force (% of population) of Denmark?
Give a very brief answer. 9.86. In the year 2003, what is the difference between the Unemployed and educated labor force (% of population) of Europe(developing only) and Unemployed and educated labor force (% of population) of Romania?
Offer a very short reply. -19.54. In the year 2003, what is the difference between the Unemployed and educated labor force (% of population) of Belarus and Unemployed and educated labor force (% of population) of Denmark?
Give a very brief answer. -22.1. In the year 2003, what is the difference between the Unemployed and educated labor force (% of population) in Belarus and Unemployed and educated labor force (% of population) in Romania?
Your answer should be very brief. -51.5. In the year 2003, what is the difference between the Unemployed and educated labor force (% of population) of Denmark and Unemployed and educated labor force (% of population) of Romania?
Provide a succinct answer. -29.4. In the year 2004, what is the difference between the Unemployed and educated labor force (% of population) of Europe(developing only) and Unemployed and educated labor force (% of population) of Belarus?
Your response must be concise. 9.03. In the year 2004, what is the difference between the Unemployed and educated labor force (% of population) in Europe(developing only) and Unemployed and educated labor force (% of population) in Denmark?
Your answer should be very brief. 0.93. In the year 2004, what is the difference between the Unemployed and educated labor force (% of population) in Europe(developing only) and Unemployed and educated labor force (% of population) in Romania?
Keep it short and to the point. -16.07. In the year 2004, what is the difference between the Unemployed and educated labor force (% of population) of Belarus and Unemployed and educated labor force (% of population) of Denmark?
Keep it short and to the point. -8.1. In the year 2004, what is the difference between the Unemployed and educated labor force (% of population) in Belarus and Unemployed and educated labor force (% of population) in Romania?
Make the answer very short. -25.1. In the year 2004, what is the difference between the Unemployed and educated labor force (% of population) of Denmark and Unemployed and educated labor force (% of population) of Romania?
Provide a short and direct response. -17. What is the ratio of the Unemployed and educated labor force (% of population) in Belarus in 1997 to that in 1998?
Offer a terse response. 1.09. What is the ratio of the Unemployed and educated labor force (% of population) in Denmark in 1997 to that in 1998?
Your response must be concise. 0.96. What is the ratio of the Unemployed and educated labor force (% of population) in Romania in 1997 to that in 1998?
Offer a terse response. 0.9. What is the ratio of the Unemployed and educated labor force (% of population) of Europe(developing only) in 1997 to that in 1999?
Offer a very short reply. 0.81. What is the ratio of the Unemployed and educated labor force (% of population) of Belarus in 1997 to that in 1999?
Offer a terse response. 1.18. What is the ratio of the Unemployed and educated labor force (% of population) in Romania in 1997 to that in 1999?
Your response must be concise. 0.91. What is the ratio of the Unemployed and educated labor force (% of population) of Europe(developing only) in 1997 to that in 2000?
Make the answer very short. 0.79. What is the ratio of the Unemployed and educated labor force (% of population) in Belarus in 1997 to that in 2000?
Provide a short and direct response. 1.25. What is the ratio of the Unemployed and educated labor force (% of population) in Denmark in 1997 to that in 2000?
Provide a short and direct response. 0.92. What is the ratio of the Unemployed and educated labor force (% of population) of Romania in 1997 to that in 2000?
Offer a terse response. 0.91. What is the ratio of the Unemployed and educated labor force (% of population) of Europe(developing only) in 1997 to that in 2001?
Provide a short and direct response. 0.83. What is the ratio of the Unemployed and educated labor force (% of population) in Belarus in 1997 to that in 2001?
Your answer should be very brief. 1.2. What is the ratio of the Unemployed and educated labor force (% of population) of Romania in 1997 to that in 2001?
Keep it short and to the point. 0.93. What is the ratio of the Unemployed and educated labor force (% of population) of Europe(developing only) in 1997 to that in 2002?
Provide a short and direct response. 0.84. What is the ratio of the Unemployed and educated labor force (% of population) of Belarus in 1997 to that in 2002?
Your answer should be very brief. 1.05. What is the ratio of the Unemployed and educated labor force (% of population) in Denmark in 1997 to that in 2002?
Make the answer very short. 1.04. What is the ratio of the Unemployed and educated labor force (% of population) in Romania in 1997 to that in 2002?
Offer a very short reply. 0.95. What is the ratio of the Unemployed and educated labor force (% of population) of Europe(developing only) in 1997 to that in 2003?
Your response must be concise. 0.85. What is the ratio of the Unemployed and educated labor force (% of population) in Belarus in 1997 to that in 2003?
Your answer should be very brief. 1.01. What is the ratio of the Unemployed and educated labor force (% of population) in Denmark in 1997 to that in 2003?
Provide a short and direct response. 1.18. What is the ratio of the Unemployed and educated labor force (% of population) in Europe(developing only) in 1997 to that in 2004?
Your response must be concise. 0.86. What is the ratio of the Unemployed and educated labor force (% of population) of Belarus in 1997 to that in 2004?
Make the answer very short. 0.45. What is the ratio of the Unemployed and educated labor force (% of population) of Denmark in 1997 to that in 2004?
Your response must be concise. 0.98. What is the ratio of the Unemployed and educated labor force (% of population) in Romania in 1997 to that in 2004?
Make the answer very short. 1.05. What is the ratio of the Unemployed and educated labor force (% of population) in Europe(developing only) in 1998 to that in 1999?
Offer a very short reply. 0.81. What is the ratio of the Unemployed and educated labor force (% of population) in Belarus in 1998 to that in 1999?
Give a very brief answer. 1.08. What is the ratio of the Unemployed and educated labor force (% of population) of Denmark in 1998 to that in 1999?
Provide a succinct answer. 0.98. What is the ratio of the Unemployed and educated labor force (% of population) in Romania in 1998 to that in 1999?
Offer a terse response. 1.01. What is the ratio of the Unemployed and educated labor force (% of population) of Europe(developing only) in 1998 to that in 2000?
Give a very brief answer. 0.79. What is the ratio of the Unemployed and educated labor force (% of population) in Belarus in 1998 to that in 2000?
Provide a succinct answer. 1.15. What is the ratio of the Unemployed and educated labor force (% of population) of Denmark in 1998 to that in 2000?
Ensure brevity in your answer.  0.96. What is the ratio of the Unemployed and educated labor force (% of population) of Romania in 1998 to that in 2000?
Your answer should be compact. 1.01. What is the ratio of the Unemployed and educated labor force (% of population) of Europe(developing only) in 1998 to that in 2001?
Keep it short and to the point. 0.83. What is the ratio of the Unemployed and educated labor force (% of population) of Belarus in 1998 to that in 2001?
Ensure brevity in your answer.  1.1. What is the ratio of the Unemployed and educated labor force (% of population) in Denmark in 1998 to that in 2001?
Ensure brevity in your answer.  0.97. What is the ratio of the Unemployed and educated labor force (% of population) of Romania in 1998 to that in 2001?
Your answer should be very brief. 1.04. What is the ratio of the Unemployed and educated labor force (% of population) in Europe(developing only) in 1998 to that in 2002?
Make the answer very short. 0.84. What is the ratio of the Unemployed and educated labor force (% of population) of Belarus in 1998 to that in 2002?
Provide a short and direct response. 0.97. What is the ratio of the Unemployed and educated labor force (% of population) in Denmark in 1998 to that in 2002?
Keep it short and to the point. 1.08. What is the ratio of the Unemployed and educated labor force (% of population) in Romania in 1998 to that in 2002?
Your response must be concise. 1.05. What is the ratio of the Unemployed and educated labor force (% of population) of Europe(developing only) in 1998 to that in 2003?
Ensure brevity in your answer.  0.85. What is the ratio of the Unemployed and educated labor force (% of population) of Belarus in 1998 to that in 2003?
Offer a terse response. 0.93. What is the ratio of the Unemployed and educated labor force (% of population) of Denmark in 1998 to that in 2003?
Your answer should be compact. 1.23. What is the ratio of the Unemployed and educated labor force (% of population) of Romania in 1998 to that in 2003?
Your answer should be compact. 1.1. What is the ratio of the Unemployed and educated labor force (% of population) in Europe(developing only) in 1998 to that in 2004?
Provide a short and direct response. 0.85. What is the ratio of the Unemployed and educated labor force (% of population) in Belarus in 1998 to that in 2004?
Offer a very short reply. 0.41. What is the ratio of the Unemployed and educated labor force (% of population) in Denmark in 1998 to that in 2004?
Keep it short and to the point. 1.02. What is the ratio of the Unemployed and educated labor force (% of population) in Romania in 1998 to that in 2004?
Ensure brevity in your answer.  1.17. What is the ratio of the Unemployed and educated labor force (% of population) in Europe(developing only) in 1999 to that in 2000?
Your response must be concise. 0.98. What is the ratio of the Unemployed and educated labor force (% of population) of Belarus in 1999 to that in 2000?
Your answer should be very brief. 1.06. What is the ratio of the Unemployed and educated labor force (% of population) in Denmark in 1999 to that in 2000?
Your answer should be compact. 0.97. What is the ratio of the Unemployed and educated labor force (% of population) in Romania in 1999 to that in 2000?
Provide a short and direct response. 1. What is the ratio of the Unemployed and educated labor force (% of population) in Europe(developing only) in 1999 to that in 2001?
Ensure brevity in your answer.  1.03. What is the ratio of the Unemployed and educated labor force (% of population) of Belarus in 1999 to that in 2001?
Provide a succinct answer. 1.01. What is the ratio of the Unemployed and educated labor force (% of population) in Denmark in 1999 to that in 2001?
Your answer should be very brief. 0.99. What is the ratio of the Unemployed and educated labor force (% of population) of Romania in 1999 to that in 2001?
Your answer should be compact. 1.03. What is the ratio of the Unemployed and educated labor force (% of population) of Europe(developing only) in 1999 to that in 2002?
Your answer should be compact. 1.04. What is the ratio of the Unemployed and educated labor force (% of population) of Belarus in 1999 to that in 2002?
Your answer should be compact. 0.89. What is the ratio of the Unemployed and educated labor force (% of population) in Denmark in 1999 to that in 2002?
Provide a succinct answer. 1.1. What is the ratio of the Unemployed and educated labor force (% of population) in Romania in 1999 to that in 2002?
Your answer should be compact. 1.04. What is the ratio of the Unemployed and educated labor force (% of population) of Europe(developing only) in 1999 to that in 2003?
Your answer should be very brief. 1.05. What is the ratio of the Unemployed and educated labor force (% of population) in Belarus in 1999 to that in 2003?
Give a very brief answer. 0.86. What is the ratio of the Unemployed and educated labor force (% of population) in Denmark in 1999 to that in 2003?
Your answer should be compact. 1.25. What is the ratio of the Unemployed and educated labor force (% of population) of Romania in 1999 to that in 2003?
Your response must be concise. 1.09. What is the ratio of the Unemployed and educated labor force (% of population) in Europe(developing only) in 1999 to that in 2004?
Your answer should be very brief. 1.06. What is the ratio of the Unemployed and educated labor force (% of population) of Belarus in 1999 to that in 2004?
Provide a succinct answer. 0.38. What is the ratio of the Unemployed and educated labor force (% of population) of Denmark in 1999 to that in 2004?
Offer a very short reply. 1.03. What is the ratio of the Unemployed and educated labor force (% of population) in Romania in 1999 to that in 2004?
Keep it short and to the point. 1.15. What is the ratio of the Unemployed and educated labor force (% of population) in Europe(developing only) in 2000 to that in 2001?
Provide a succinct answer. 1.05. What is the ratio of the Unemployed and educated labor force (% of population) of Belarus in 2000 to that in 2001?
Offer a terse response. 0.95. What is the ratio of the Unemployed and educated labor force (% of population) in Denmark in 2000 to that in 2001?
Your response must be concise. 1.01. What is the ratio of the Unemployed and educated labor force (% of population) of Romania in 2000 to that in 2001?
Ensure brevity in your answer.  1.03. What is the ratio of the Unemployed and educated labor force (% of population) of Europe(developing only) in 2000 to that in 2002?
Provide a succinct answer. 1.07. What is the ratio of the Unemployed and educated labor force (% of population) of Belarus in 2000 to that in 2002?
Ensure brevity in your answer.  0.84. What is the ratio of the Unemployed and educated labor force (% of population) in Denmark in 2000 to that in 2002?
Provide a short and direct response. 1.13. What is the ratio of the Unemployed and educated labor force (% of population) in Romania in 2000 to that in 2002?
Offer a very short reply. 1.04. What is the ratio of the Unemployed and educated labor force (% of population) of Europe(developing only) in 2000 to that in 2003?
Make the answer very short. 1.07. What is the ratio of the Unemployed and educated labor force (% of population) of Belarus in 2000 to that in 2003?
Provide a succinct answer. 0.81. What is the ratio of the Unemployed and educated labor force (% of population) of Denmark in 2000 to that in 2003?
Your answer should be compact. 1.29. What is the ratio of the Unemployed and educated labor force (% of population) in Romania in 2000 to that in 2003?
Keep it short and to the point. 1.09. What is the ratio of the Unemployed and educated labor force (% of population) of Europe(developing only) in 2000 to that in 2004?
Ensure brevity in your answer.  1.08. What is the ratio of the Unemployed and educated labor force (% of population) in Belarus in 2000 to that in 2004?
Provide a short and direct response. 0.36. What is the ratio of the Unemployed and educated labor force (% of population) in Denmark in 2000 to that in 2004?
Provide a short and direct response. 1.06. What is the ratio of the Unemployed and educated labor force (% of population) in Romania in 2000 to that in 2004?
Provide a succinct answer. 1.15. What is the ratio of the Unemployed and educated labor force (% of population) of Europe(developing only) in 2001 to that in 2002?
Keep it short and to the point. 1.01. What is the ratio of the Unemployed and educated labor force (% of population) of Belarus in 2001 to that in 2002?
Provide a short and direct response. 0.88. What is the ratio of the Unemployed and educated labor force (% of population) of Denmark in 2001 to that in 2002?
Your answer should be compact. 1.12. What is the ratio of the Unemployed and educated labor force (% of population) in Romania in 2001 to that in 2002?
Offer a terse response. 1.01. What is the ratio of the Unemployed and educated labor force (% of population) of Europe(developing only) in 2001 to that in 2003?
Your answer should be compact. 1.02. What is the ratio of the Unemployed and educated labor force (% of population) of Belarus in 2001 to that in 2003?
Your answer should be compact. 0.85. What is the ratio of the Unemployed and educated labor force (% of population) in Denmark in 2001 to that in 2003?
Provide a succinct answer. 1.27. What is the ratio of the Unemployed and educated labor force (% of population) of Romania in 2001 to that in 2003?
Keep it short and to the point. 1.06. What is the ratio of the Unemployed and educated labor force (% of population) of Europe(developing only) in 2001 to that in 2004?
Offer a terse response. 1.03. What is the ratio of the Unemployed and educated labor force (% of population) in Belarus in 2001 to that in 2004?
Give a very brief answer. 0.38. What is the ratio of the Unemployed and educated labor force (% of population) of Denmark in 2001 to that in 2004?
Provide a succinct answer. 1.05. What is the ratio of the Unemployed and educated labor force (% of population) of Romania in 2001 to that in 2004?
Offer a very short reply. 1.12. What is the ratio of the Unemployed and educated labor force (% of population) in Europe(developing only) in 2002 to that in 2003?
Your answer should be very brief. 1.01. What is the ratio of the Unemployed and educated labor force (% of population) in Belarus in 2002 to that in 2003?
Ensure brevity in your answer.  0.96. What is the ratio of the Unemployed and educated labor force (% of population) in Denmark in 2002 to that in 2003?
Keep it short and to the point. 1.14. What is the ratio of the Unemployed and educated labor force (% of population) of Romania in 2002 to that in 2003?
Make the answer very short. 1.04. What is the ratio of the Unemployed and educated labor force (% of population) of Europe(developing only) in 2002 to that in 2004?
Your response must be concise. 1.01. What is the ratio of the Unemployed and educated labor force (% of population) in Belarus in 2002 to that in 2004?
Your answer should be very brief. 0.43. What is the ratio of the Unemployed and educated labor force (% of population) in Denmark in 2002 to that in 2004?
Your response must be concise. 0.94. What is the ratio of the Unemployed and educated labor force (% of population) in Romania in 2002 to that in 2004?
Provide a short and direct response. 1.11. What is the ratio of the Unemployed and educated labor force (% of population) of Europe(developing only) in 2003 to that in 2004?
Your answer should be very brief. 1.01. What is the ratio of the Unemployed and educated labor force (% of population) in Belarus in 2003 to that in 2004?
Provide a short and direct response. 0.45. What is the ratio of the Unemployed and educated labor force (% of population) of Denmark in 2003 to that in 2004?
Give a very brief answer. 0.83. What is the ratio of the Unemployed and educated labor force (% of population) in Romania in 2003 to that in 2004?
Provide a short and direct response. 1.06. What is the difference between the highest and the second highest Unemployed and educated labor force (% of population) of Europe(developing only)?
Keep it short and to the point. 1.14. What is the difference between the highest and the second highest Unemployed and educated labor force (% of population) of Belarus?
Ensure brevity in your answer.  22.3. What is the difference between the highest and the lowest Unemployed and educated labor force (% of population) of Europe(developing only)?
Offer a very short reply. 11.26. What is the difference between the highest and the lowest Unemployed and educated labor force (% of population) in Denmark?
Give a very brief answer. 11.5. 